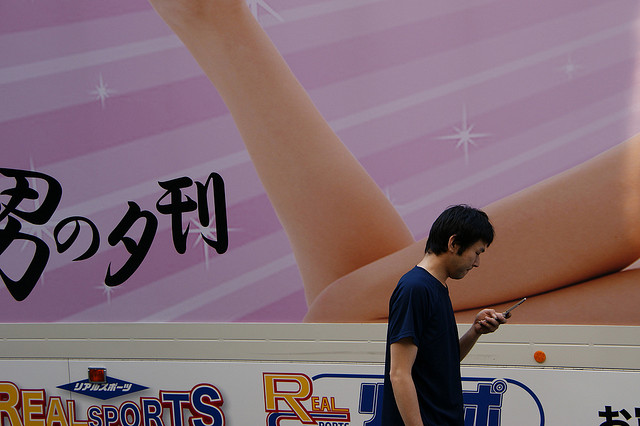<image>What words are painted on the wall? I am not sure what words are painted on the wall. It can be 'real sports' or 'graffiti'. What words are painted on the wall? I don't know what words are painted on the wall. It can be seen 'real sports', 'not sure', 'graffiti' or 'born'. 